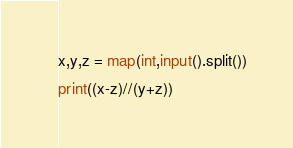Convert code to text. <code><loc_0><loc_0><loc_500><loc_500><_Python_>x,y,z = map(int,input().split())
print((x-z)//(y+z))</code> 